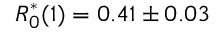<formula> <loc_0><loc_0><loc_500><loc_500>R _ { 0 } ^ { * } ( 1 ) = 0 . 4 1 \pm 0 . 0 3</formula> 